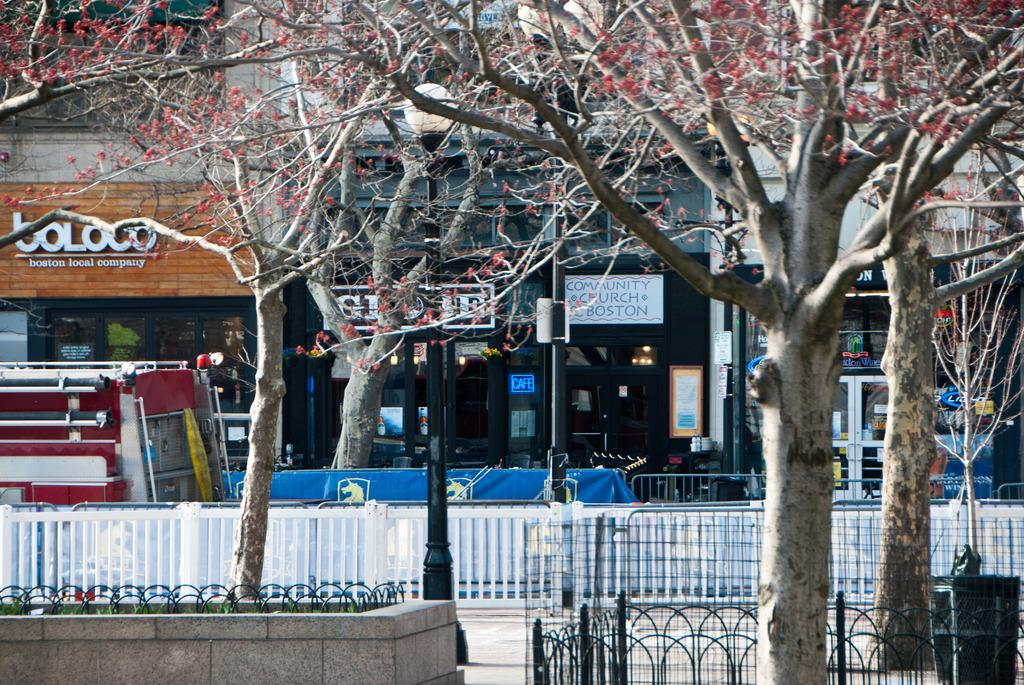What type of structure is visible in the image? There is a building in the image. What features can be seen on the building? The building has doors. What type of natural elements are present in the image? There are trees in the image. What type of man-made infrastructure is present in the image? There is a road and street poles in the image. What additional object can be seen in the image? There is a board in the image. Can you tell me what mark the dad made on the worm in the image? There is no dad, mark, or worm present in the image. 